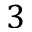Convert formula to latex. <formula><loc_0><loc_0><loc_500><loc_500>3</formula> 